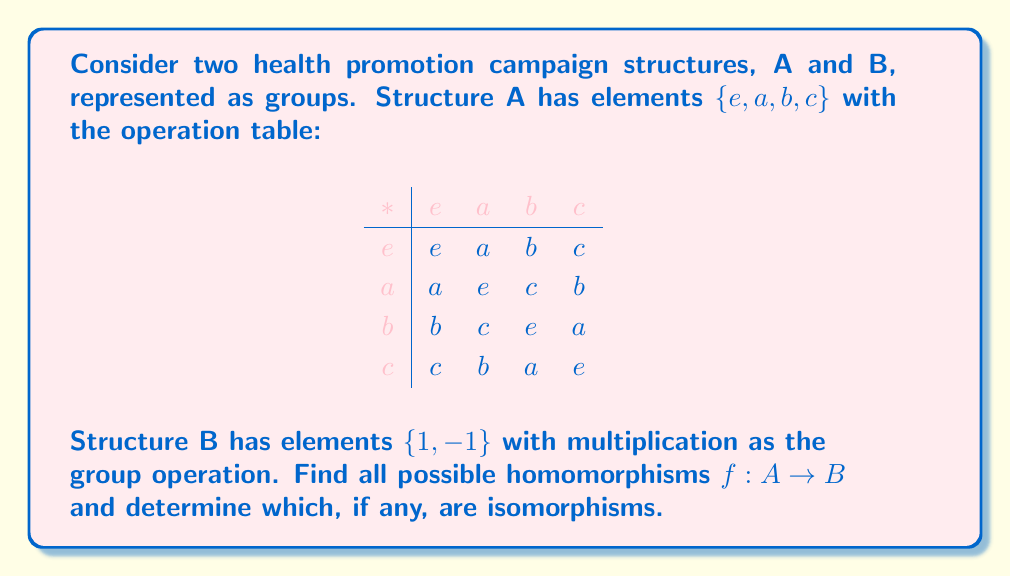Teach me how to tackle this problem. To solve this problem, we need to follow these steps:

1) First, we need to identify the properties of groups A and B:
   - Group A is isomorphic to the Klein four-group V4.
   - Group B is isomorphic to the cyclic group of order 2, C2.

2) A homomorphism $f: A \rightarrow B$ must satisfy the property $f(x * y) = f(x) \cdot f(y)$ for all $x, y \in A$.

3) Since B has only two elements, each element of A must map to either 1 or -1.

4) The identity element of A (e) must always map to the identity element of B (1).

5) Now, let's consider the possible mappings for a, b, and c:

   Case 1: If $f(a) = f(b) = f(c) = 1$, then $f$ is a valid homomorphism.
   
   Case 2: If $f(a) = -1, f(b) = f(c) = 1$, then $f$ is a valid homomorphism.
   
   Case 3: If $f(a) = 1, f(b) = -1, f(c) = 1$, then $f$ is a valid homomorphism.
   
   Case 4: If $f(a) = 1, f(b) = 1, f(c) = -1$, then $f$ is a valid homomorphism.

6) We can verify that these are all possible homomorphisms by checking that $f(x * y) = f(x) \cdot f(y)$ for all $x, y \in A$ in each case.

7) An isomorphism is a bijective homomorphism. For a homomorphism to be bijective:
   - It must be surjective (onto): The image of $f$ must include both elements of B.
   - It must be injective (one-to-one): No two elements of A can map to the same element of B.

8) Examining our homomorphisms:
   - Case 1 is not surjective, so it's not an isomorphism.
   - Cases 2, 3, and 4 are surjective but not injective, so they're not isomorphisms.

Therefore, none of the homomorphisms are isomorphisms.
Answer: There are four homomorphisms from A to B:

1) $f_1(e) = 1, f_1(a) = 1, f_1(b) = 1, f_1(c) = 1$
2) $f_2(e) = 1, f_2(a) = -1, f_2(b) = 1, f_2(c) = 1$
3) $f_3(e) = 1, f_3(a) = 1, f_3(b) = -1, f_3(c) = 1$
4) $f_4(e) = 1, f_4(a) = 1, f_4(b) = 1, f_4(c) = -1$

None of these homomorphisms are isomorphisms. 